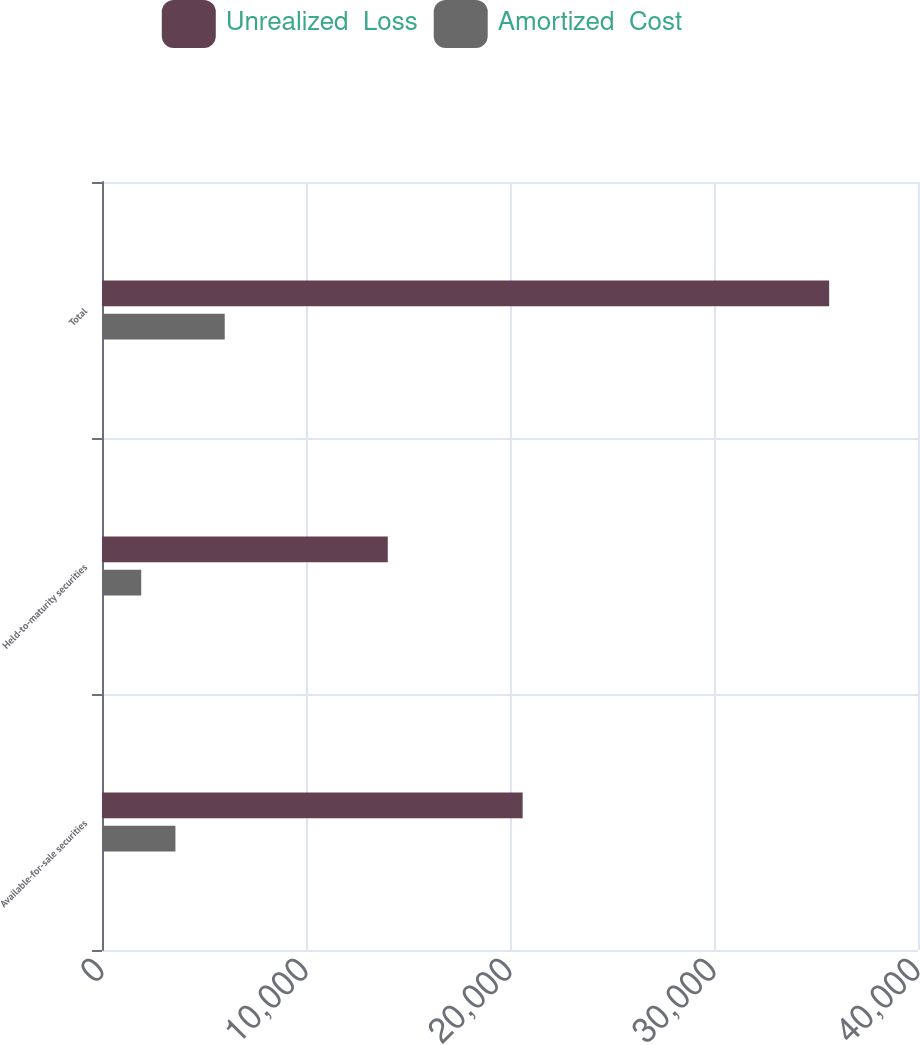Convert chart to OTSL. <chart><loc_0><loc_0><loc_500><loc_500><stacked_bar_chart><ecel><fcel>Available-for-sale securities<fcel>Held-to-maturity securities<fcel>Total<nl><fcel>Unrealized  Loss<fcel>20620<fcel>14009<fcel>35645<nl><fcel>Amortized  Cost<fcel>3599<fcel>1923<fcel>6016<nl></chart> 